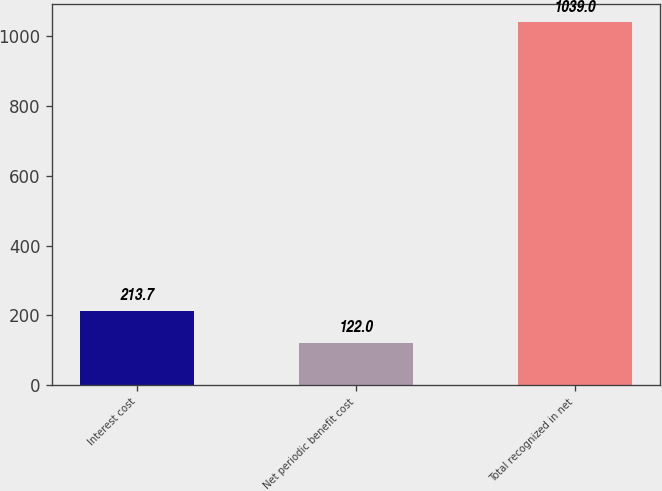<chart> <loc_0><loc_0><loc_500><loc_500><bar_chart><fcel>Interest cost<fcel>Net periodic benefit cost<fcel>Total recognized in net<nl><fcel>213.7<fcel>122<fcel>1039<nl></chart> 